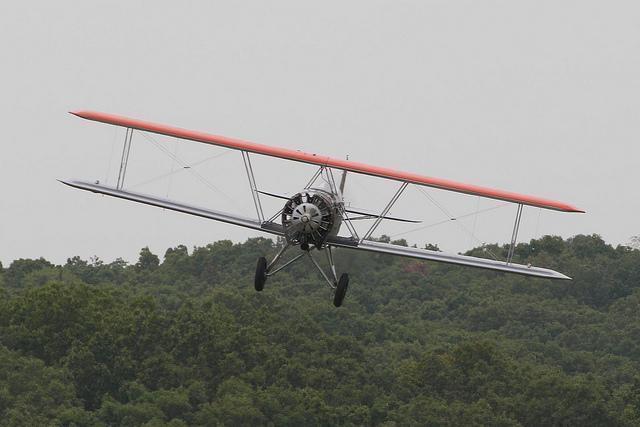How many airplanes are there?
Give a very brief answer. 1. How many zebra are there?
Give a very brief answer. 0. 